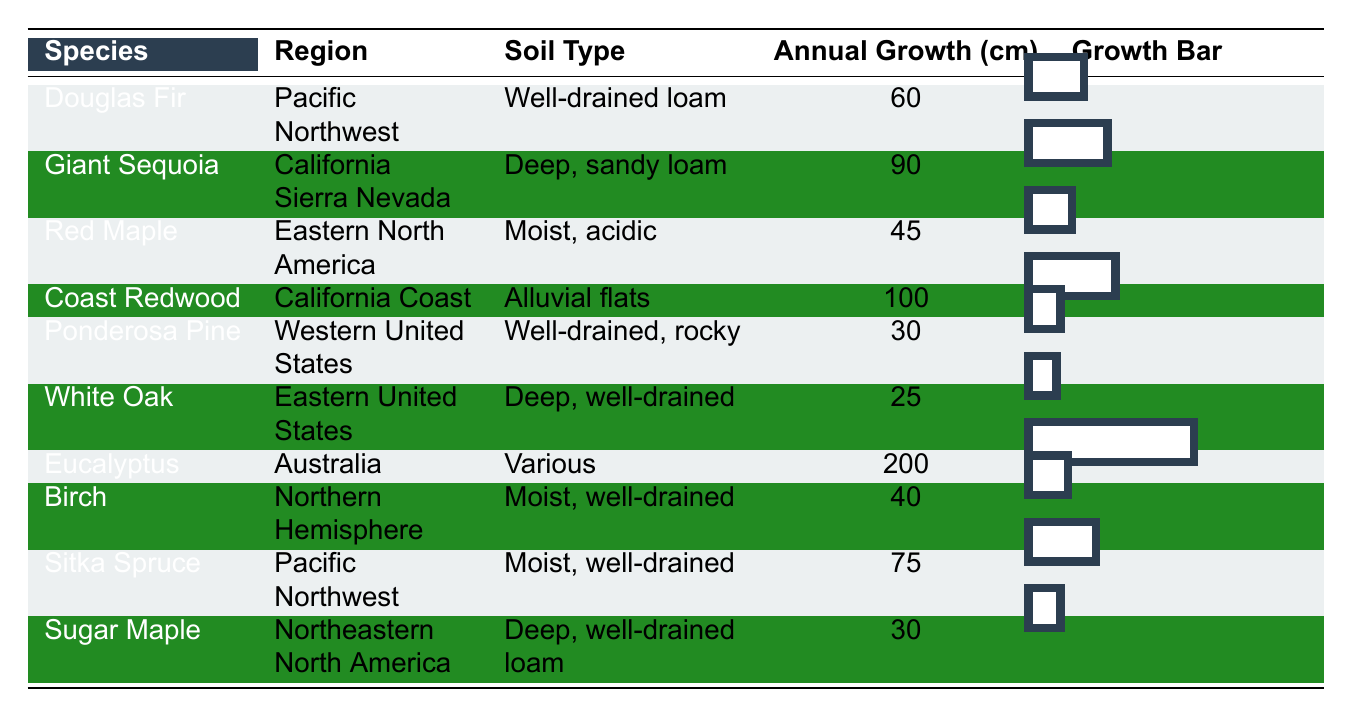What tree species has the highest annual growth rate? The table shows the annual growth rates of various tree species. Looking through the "Annual Growth (cm)" column, Eucalyptus has the highest growth rate at 200 cm.
Answer: Eucalyptus How many tree species have an annual growth rate greater than 70 cm? From the table, we see that the species with growth rates greater than 70 cm are Giant Sequoia (90 cm), Coast Redwood (100 cm), Sitka Spruce (75 cm), and Eucalyptus (200 cm). There are four species in total.
Answer: 4 What is the annual growth rate of the White Oak? Referring to the table, the annual growth rate for White Oak is listed in the "Annual Growth (cm)" column as 25 cm.
Answer: 25 cm Which region is associated with the Coast Redwood? The table indicates that Coast Redwood is associated with the region "California Coast."
Answer: California Coast What is the difference in annual growth rates between the Eucalyptus and the Ponderosa Pine? By examining the growth rates, Eucalyptus has a growth rate of 200 cm, while Ponderosa Pine has a growth rate of 30 cm. The difference is calculated as 200 - 30 = 170 cm.
Answer: 170 cm Are there any trees from the Pacific Northwest with annual growth rates above 70 cm? The table lists Douglas Fir and Sitka Spruce as the species from the Pacific Northwest. Douglas Fir has an annual growth rate of 60 cm, which is not above 70 cm, but Sitka Spruce at 75 cm is. Therefore, yes, there is one tree that meets this criteria.
Answer: Yes What is the average annual growth rate of all species listed in the table? To find the average, we need to sum the growth rates (60 + 90 + 45 + 100 + 30 + 25 + 200 + 40 + 75 + 30 = 650 cm) and divide by the number of species (10). Therefore, the average is 650/10 = 65 cm.
Answer: 65 cm Which tree species has the lowest growth rate, and what is that rate? Scanning the "Annual Growth (cm)" column reveals that White Oak has the lowest growth rate of 25 cm.
Answer: White Oak, 25 cm Which tree species in the Eastern United States has the highest growth rate? The table shows that White Oak (25 cm) and Red Maple (45 cm) are both in the Eastern United States, and among these, Red Maple has the higher growth rate of 45 cm.
Answer: Red Maple, 45 cm If the region of Australia were to plant another Eucalyptus tree, how would it affect the overall average growth rate? The average before adding another Eucalyptus is 65 cm. An additional Eucalyptus (200 cm) increases the total growth to 650 + 200 = 850 cm and increases the count of species to 11. Thus, the new average is 850/11 ≈ 77.27 cm. The overall average growth rate would increase.
Answer: Yes, it would increase 